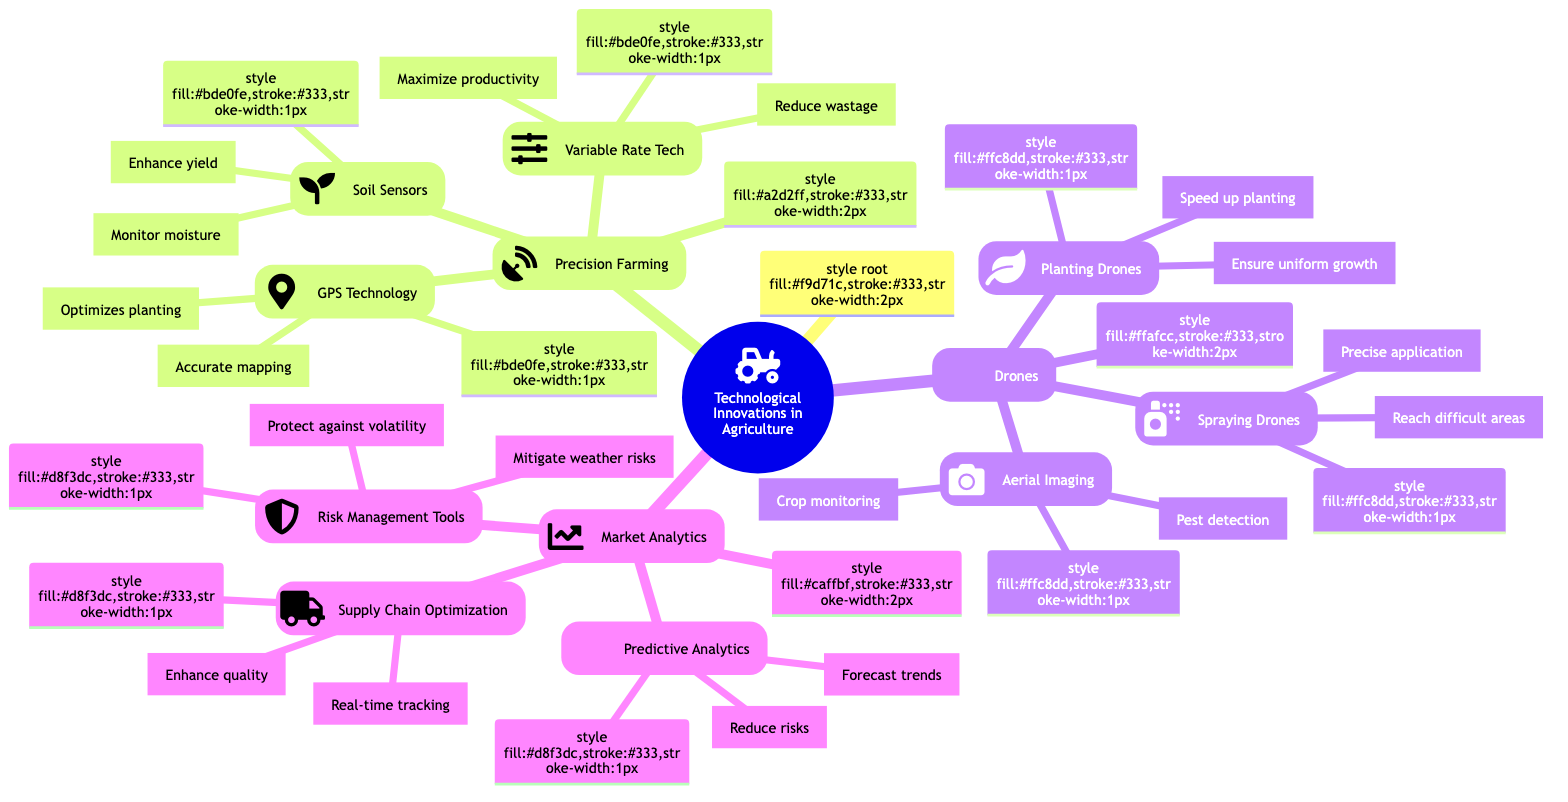What is the primary purpose of GPS Technology in Precision Farming? The diagram indicates that the primary purpose of GPS Technology is "Accurate field mapping and soil sampling." This can be located under the Precision Farming section within the GPS Technology node.
Answer: Accurate field mapping and soil sampling How many main categories are there in Technological Innovations in Agriculture? By examining the diagram, I can identify three main categories listed under Technological Innovations in Agriculture: Precision Farming, Drones, and Market Analytics.
Answer: Three What are the benefits of using Soil Sensors in Precision Farming? The diagram shows that Soil Sensors have two benefits: "Improves irrigation efficiency" and "Enhances crop yield." Both benefits are listed directly under the Soil Sensors node within the Precision Farming section.
Answer: Improves irrigation efficiency, Enhances crop yield Which type of drone is associated with precision application of pesticides and fertilizers? The diagram points to the "Spraying Drones" node, which specifies that they are responsible for the "Precise application of pesticides and fertilizers." This node is located under the Drones category.
Answer: Spraying Drones What technology helps forecast market trends as part of Market Analytics? Looking at the diagram, I can see that "Predictive Analytics" serves the purpose of forecasting market trends and prices. This node is grouped within the Market Analytics section.
Answer: Predictive Analytics What are the two main benefits of Variable Rate Technology in Precision Farming? Upon inspecting the Variable Rate Technology node, I discover two benefits: "Reduces input wastage" and "Maximizes crop productivity." These benefits are specified directly under that node.
Answer: Reduces input wastage, Maximizes crop productivity Which example is given for Risk Management Tools under Market Analytics? The diagram lists two examples under the Risk Management Tools node, one of which is "Climate Corporation." I can find this under the corresponding Market Analytics section.
Answer: Climate Corporation What is a key benefit of using drones for aerial imaging? According to the diagram, a key benefit of using drones for aerial imaging is "Identifies pest infestations." This benefit is indicated directly under the Aerial Imaging node within the Drones category.
Answer: Identifies pest infestations How does Supply Chain Optimization contribute to agricultural processes? The diagram states that Supply Chain Optimization allows for "Real-time tracking and management," which minimizes supply chain disruptions and enhances product quality. This information can be found under the Supply Chain Optimization node in Market Analytics.
Answer: Real-time tracking and management 